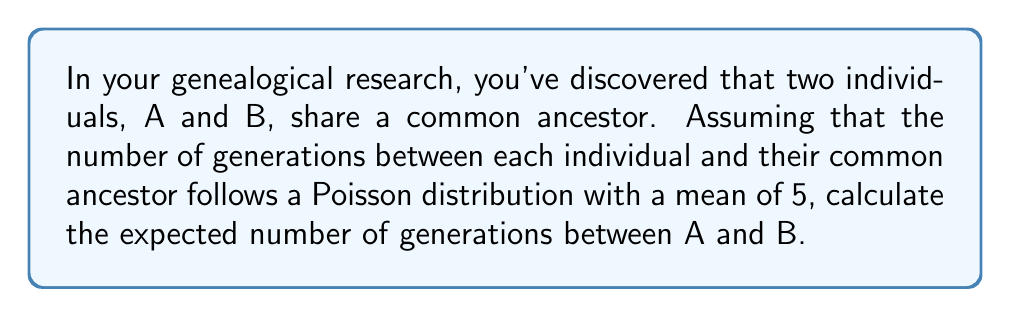What is the answer to this math problem? Let's approach this step-by-step:

1) Let $X$ be the number of generations between individual A and the common ancestor, and $Y$ be the number of generations between individual B and the common ancestor.

2) Given: $X$ and $Y$ follow Poisson distributions with mean 5.
   $X \sim \text{Poisson}(5)$ and $Y \sim \text{Poisson}(5)$

3) The number of generations between A and B is the sum of X and Y: $Z = X + Y$

4) A key property of Poisson distributions is that the sum of two independent Poisson random variables is also a Poisson random variable, with a mean equal to the sum of the means of the original distributions.

5) Therefore, $Z \sim \text{Poisson}(5+5) = \text{Poisson}(10)$

6) The expected value of a Poisson distribution is equal to its mean parameter. So:

   $E[Z] = 10$

Thus, the expected number of generations between A and B is 10.
Answer: 10 generations 